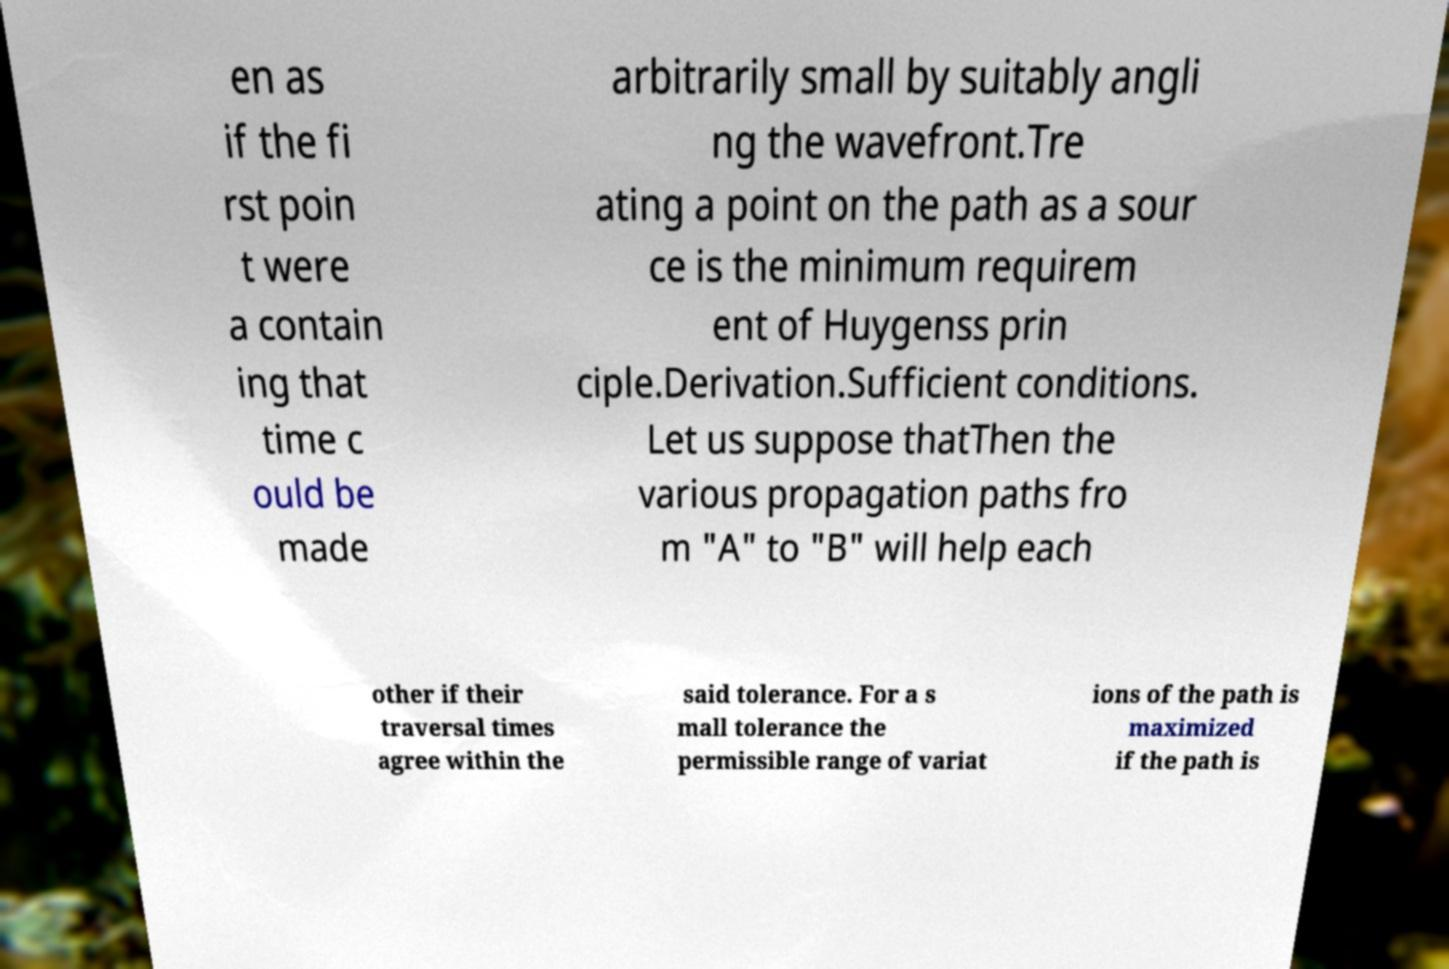Please identify and transcribe the text found in this image. en as if the fi rst poin t were a contain ing that time c ould be made arbitrarily small by suitably angli ng the wavefront.Tre ating a point on the path as a sour ce is the minimum requirem ent of Huygenss prin ciple.Derivation.Sufficient conditions. Let us suppose thatThen the various propagation paths fro m "A" to "B" will help each other if their traversal times agree within the said tolerance. For a s mall tolerance the permissible range of variat ions of the path is maximized if the path is 